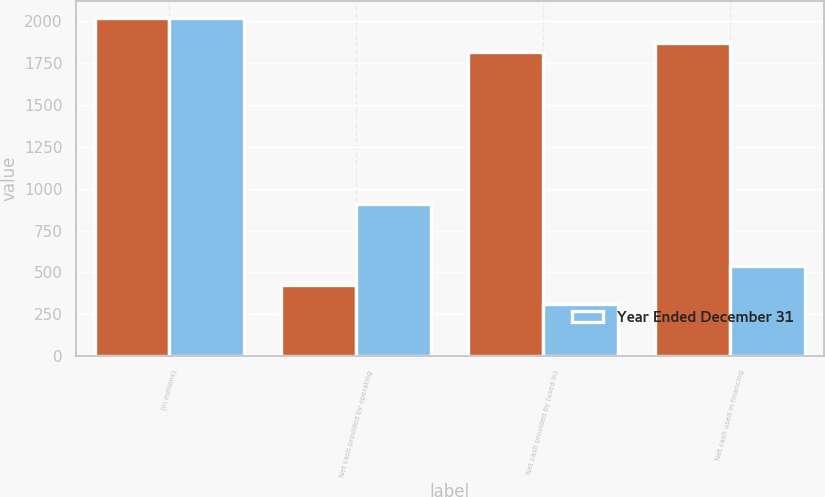Convert chart. <chart><loc_0><loc_0><loc_500><loc_500><stacked_bar_chart><ecel><fcel>(In millions)<fcel>Net cash provided by operating<fcel>Net cash provided by (used in)<fcel>Net cash used in financing<nl><fcel>nan<fcel>2017<fcel>424.4<fcel>1813.6<fcel>1864.3<nl><fcel>Year Ended December 31<fcel>2016<fcel>906.9<fcel>314.8<fcel>540.9<nl></chart> 